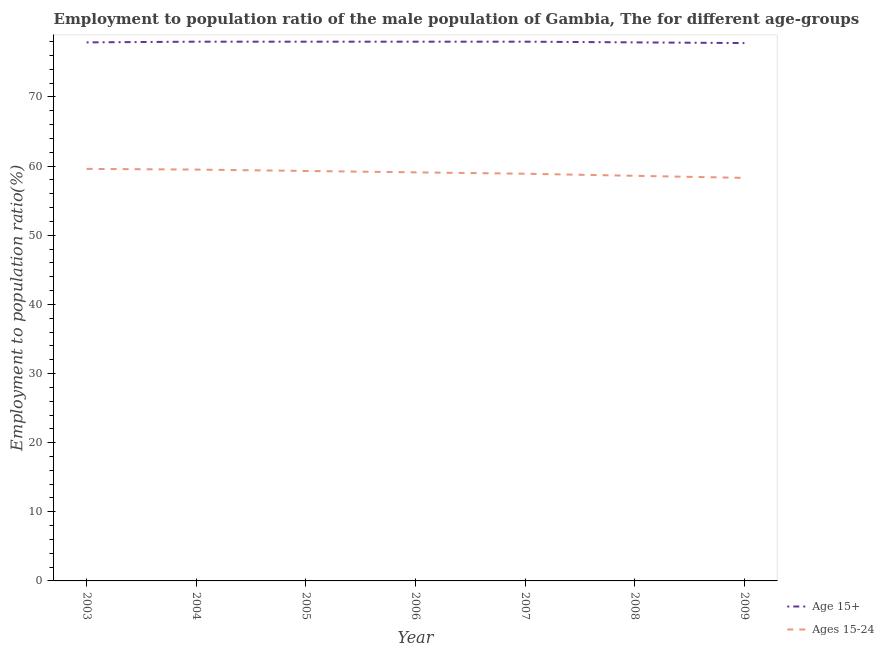How many different coloured lines are there?
Your answer should be compact. 2. Does the line corresponding to employment to population ratio(age 15-24) intersect with the line corresponding to employment to population ratio(age 15+)?
Provide a short and direct response. No. Is the number of lines equal to the number of legend labels?
Provide a succinct answer. Yes. What is the employment to population ratio(age 15+) in 2006?
Your answer should be compact. 78. Across all years, what is the maximum employment to population ratio(age 15-24)?
Your answer should be compact. 59.6. Across all years, what is the minimum employment to population ratio(age 15+)?
Your answer should be very brief. 77.8. In which year was the employment to population ratio(age 15-24) maximum?
Give a very brief answer. 2003. What is the total employment to population ratio(age 15+) in the graph?
Your answer should be very brief. 545.6. What is the difference between the employment to population ratio(age 15-24) in 2004 and that in 2005?
Your answer should be very brief. 0.2. What is the difference between the employment to population ratio(age 15-24) in 2005 and the employment to population ratio(age 15+) in 2007?
Your response must be concise. -18.7. What is the average employment to population ratio(age 15+) per year?
Ensure brevity in your answer.  77.94. In the year 2006, what is the difference between the employment to population ratio(age 15+) and employment to population ratio(age 15-24)?
Offer a very short reply. 18.9. In how many years, is the employment to population ratio(age 15+) greater than 66 %?
Your answer should be compact. 7. What is the ratio of the employment to population ratio(age 15-24) in 2004 to that in 2009?
Your answer should be very brief. 1.02. Is the employment to population ratio(age 15+) in 2007 less than that in 2009?
Give a very brief answer. No. What is the difference between the highest and the second highest employment to population ratio(age 15-24)?
Offer a terse response. 0.1. What is the difference between the highest and the lowest employment to population ratio(age 15+)?
Provide a short and direct response. 0.2. In how many years, is the employment to population ratio(age 15-24) greater than the average employment to population ratio(age 15-24) taken over all years?
Give a very brief answer. 4. Where does the legend appear in the graph?
Ensure brevity in your answer.  Bottom right. How are the legend labels stacked?
Give a very brief answer. Vertical. What is the title of the graph?
Offer a very short reply. Employment to population ratio of the male population of Gambia, The for different age-groups. Does "Merchandise imports" appear as one of the legend labels in the graph?
Offer a very short reply. No. What is the label or title of the X-axis?
Make the answer very short. Year. What is the label or title of the Y-axis?
Give a very brief answer. Employment to population ratio(%). What is the Employment to population ratio(%) in Age 15+ in 2003?
Your answer should be very brief. 77.9. What is the Employment to population ratio(%) of Ages 15-24 in 2003?
Make the answer very short. 59.6. What is the Employment to population ratio(%) of Ages 15-24 in 2004?
Your answer should be very brief. 59.5. What is the Employment to population ratio(%) in Age 15+ in 2005?
Provide a short and direct response. 78. What is the Employment to population ratio(%) of Ages 15-24 in 2005?
Offer a terse response. 59.3. What is the Employment to population ratio(%) in Ages 15-24 in 2006?
Keep it short and to the point. 59.1. What is the Employment to population ratio(%) in Ages 15-24 in 2007?
Offer a terse response. 58.9. What is the Employment to population ratio(%) in Age 15+ in 2008?
Give a very brief answer. 77.9. What is the Employment to population ratio(%) of Ages 15-24 in 2008?
Make the answer very short. 58.6. What is the Employment to population ratio(%) of Age 15+ in 2009?
Your response must be concise. 77.8. What is the Employment to population ratio(%) of Ages 15-24 in 2009?
Make the answer very short. 58.3. Across all years, what is the maximum Employment to population ratio(%) of Age 15+?
Provide a short and direct response. 78. Across all years, what is the maximum Employment to population ratio(%) of Ages 15-24?
Offer a terse response. 59.6. Across all years, what is the minimum Employment to population ratio(%) of Age 15+?
Keep it short and to the point. 77.8. Across all years, what is the minimum Employment to population ratio(%) of Ages 15-24?
Your answer should be very brief. 58.3. What is the total Employment to population ratio(%) of Age 15+ in the graph?
Your response must be concise. 545.6. What is the total Employment to population ratio(%) of Ages 15-24 in the graph?
Ensure brevity in your answer.  413.3. What is the difference between the Employment to population ratio(%) in Ages 15-24 in 2003 and that in 2004?
Your answer should be very brief. 0.1. What is the difference between the Employment to population ratio(%) in Ages 15-24 in 2003 and that in 2005?
Provide a succinct answer. 0.3. What is the difference between the Employment to population ratio(%) of Ages 15-24 in 2003 and that in 2008?
Keep it short and to the point. 1. What is the difference between the Employment to population ratio(%) in Age 15+ in 2003 and that in 2009?
Keep it short and to the point. 0.1. What is the difference between the Employment to population ratio(%) in Ages 15-24 in 2004 and that in 2005?
Provide a succinct answer. 0.2. What is the difference between the Employment to population ratio(%) in Ages 15-24 in 2004 and that in 2006?
Offer a very short reply. 0.4. What is the difference between the Employment to population ratio(%) in Age 15+ in 2004 and that in 2008?
Your answer should be very brief. 0.1. What is the difference between the Employment to population ratio(%) of Age 15+ in 2005 and that in 2006?
Keep it short and to the point. 0. What is the difference between the Employment to population ratio(%) of Age 15+ in 2005 and that in 2007?
Give a very brief answer. 0. What is the difference between the Employment to population ratio(%) in Ages 15-24 in 2005 and that in 2007?
Your response must be concise. 0.4. What is the difference between the Employment to population ratio(%) of Age 15+ in 2005 and that in 2008?
Make the answer very short. 0.1. What is the difference between the Employment to population ratio(%) in Ages 15-24 in 2005 and that in 2009?
Give a very brief answer. 1. What is the difference between the Employment to population ratio(%) in Age 15+ in 2006 and that in 2007?
Provide a short and direct response. 0. What is the difference between the Employment to population ratio(%) of Ages 15-24 in 2006 and that in 2009?
Offer a terse response. 0.8. What is the difference between the Employment to population ratio(%) of Age 15+ in 2007 and that in 2008?
Your answer should be very brief. 0.1. What is the difference between the Employment to population ratio(%) in Ages 15-24 in 2007 and that in 2009?
Give a very brief answer. 0.6. What is the difference between the Employment to population ratio(%) of Age 15+ in 2003 and the Employment to population ratio(%) of Ages 15-24 in 2005?
Give a very brief answer. 18.6. What is the difference between the Employment to population ratio(%) of Age 15+ in 2003 and the Employment to population ratio(%) of Ages 15-24 in 2006?
Provide a succinct answer. 18.8. What is the difference between the Employment to population ratio(%) of Age 15+ in 2003 and the Employment to population ratio(%) of Ages 15-24 in 2007?
Your answer should be very brief. 19. What is the difference between the Employment to population ratio(%) of Age 15+ in 2003 and the Employment to population ratio(%) of Ages 15-24 in 2008?
Provide a short and direct response. 19.3. What is the difference between the Employment to population ratio(%) in Age 15+ in 2003 and the Employment to population ratio(%) in Ages 15-24 in 2009?
Make the answer very short. 19.6. What is the difference between the Employment to population ratio(%) of Age 15+ in 2004 and the Employment to population ratio(%) of Ages 15-24 in 2005?
Your answer should be compact. 18.7. What is the difference between the Employment to population ratio(%) in Age 15+ in 2004 and the Employment to population ratio(%) in Ages 15-24 in 2006?
Make the answer very short. 18.9. What is the difference between the Employment to population ratio(%) of Age 15+ in 2005 and the Employment to population ratio(%) of Ages 15-24 in 2006?
Give a very brief answer. 18.9. What is the difference between the Employment to population ratio(%) in Age 15+ in 2005 and the Employment to population ratio(%) in Ages 15-24 in 2007?
Offer a very short reply. 19.1. What is the difference between the Employment to population ratio(%) in Age 15+ in 2005 and the Employment to population ratio(%) in Ages 15-24 in 2008?
Offer a very short reply. 19.4. What is the difference between the Employment to population ratio(%) of Age 15+ in 2006 and the Employment to population ratio(%) of Ages 15-24 in 2008?
Your answer should be very brief. 19.4. What is the difference between the Employment to population ratio(%) of Age 15+ in 2006 and the Employment to population ratio(%) of Ages 15-24 in 2009?
Make the answer very short. 19.7. What is the difference between the Employment to population ratio(%) in Age 15+ in 2008 and the Employment to population ratio(%) in Ages 15-24 in 2009?
Give a very brief answer. 19.6. What is the average Employment to population ratio(%) in Age 15+ per year?
Provide a succinct answer. 77.94. What is the average Employment to population ratio(%) of Ages 15-24 per year?
Offer a terse response. 59.04. In the year 2003, what is the difference between the Employment to population ratio(%) in Age 15+ and Employment to population ratio(%) in Ages 15-24?
Keep it short and to the point. 18.3. In the year 2006, what is the difference between the Employment to population ratio(%) of Age 15+ and Employment to population ratio(%) of Ages 15-24?
Offer a terse response. 18.9. In the year 2007, what is the difference between the Employment to population ratio(%) in Age 15+ and Employment to population ratio(%) in Ages 15-24?
Your response must be concise. 19.1. In the year 2008, what is the difference between the Employment to population ratio(%) in Age 15+ and Employment to population ratio(%) in Ages 15-24?
Your answer should be very brief. 19.3. In the year 2009, what is the difference between the Employment to population ratio(%) of Age 15+ and Employment to population ratio(%) of Ages 15-24?
Provide a short and direct response. 19.5. What is the ratio of the Employment to population ratio(%) of Age 15+ in 2003 to that in 2005?
Provide a succinct answer. 1. What is the ratio of the Employment to population ratio(%) of Ages 15-24 in 2003 to that in 2005?
Ensure brevity in your answer.  1.01. What is the ratio of the Employment to population ratio(%) in Ages 15-24 in 2003 to that in 2006?
Give a very brief answer. 1.01. What is the ratio of the Employment to population ratio(%) of Age 15+ in 2003 to that in 2007?
Your answer should be very brief. 1. What is the ratio of the Employment to population ratio(%) in Ages 15-24 in 2003 to that in 2007?
Your response must be concise. 1.01. What is the ratio of the Employment to population ratio(%) of Ages 15-24 in 2003 to that in 2008?
Your answer should be compact. 1.02. What is the ratio of the Employment to population ratio(%) of Ages 15-24 in 2003 to that in 2009?
Provide a succinct answer. 1.02. What is the ratio of the Employment to population ratio(%) of Age 15+ in 2004 to that in 2005?
Your answer should be very brief. 1. What is the ratio of the Employment to population ratio(%) of Ages 15-24 in 2004 to that in 2006?
Offer a very short reply. 1.01. What is the ratio of the Employment to population ratio(%) of Ages 15-24 in 2004 to that in 2007?
Give a very brief answer. 1.01. What is the ratio of the Employment to population ratio(%) of Age 15+ in 2004 to that in 2008?
Keep it short and to the point. 1. What is the ratio of the Employment to population ratio(%) of Ages 15-24 in 2004 to that in 2008?
Your answer should be very brief. 1.02. What is the ratio of the Employment to population ratio(%) in Ages 15-24 in 2004 to that in 2009?
Your answer should be very brief. 1.02. What is the ratio of the Employment to population ratio(%) of Age 15+ in 2005 to that in 2007?
Offer a very short reply. 1. What is the ratio of the Employment to population ratio(%) in Ages 15-24 in 2005 to that in 2007?
Your answer should be compact. 1.01. What is the ratio of the Employment to population ratio(%) of Age 15+ in 2005 to that in 2008?
Ensure brevity in your answer.  1. What is the ratio of the Employment to population ratio(%) in Ages 15-24 in 2005 to that in 2008?
Your answer should be very brief. 1.01. What is the ratio of the Employment to population ratio(%) in Ages 15-24 in 2005 to that in 2009?
Offer a very short reply. 1.02. What is the ratio of the Employment to population ratio(%) in Age 15+ in 2006 to that in 2008?
Offer a terse response. 1. What is the ratio of the Employment to population ratio(%) in Ages 15-24 in 2006 to that in 2008?
Keep it short and to the point. 1.01. What is the ratio of the Employment to population ratio(%) in Age 15+ in 2006 to that in 2009?
Offer a very short reply. 1. What is the ratio of the Employment to population ratio(%) of Ages 15-24 in 2006 to that in 2009?
Give a very brief answer. 1.01. What is the ratio of the Employment to population ratio(%) of Age 15+ in 2007 to that in 2008?
Your answer should be compact. 1. What is the ratio of the Employment to population ratio(%) of Ages 15-24 in 2007 to that in 2008?
Offer a terse response. 1.01. What is the ratio of the Employment to population ratio(%) of Age 15+ in 2007 to that in 2009?
Provide a succinct answer. 1. What is the ratio of the Employment to population ratio(%) of Ages 15-24 in 2007 to that in 2009?
Provide a succinct answer. 1.01. What is the ratio of the Employment to population ratio(%) in Age 15+ in 2008 to that in 2009?
Offer a very short reply. 1. What is the ratio of the Employment to population ratio(%) in Ages 15-24 in 2008 to that in 2009?
Your answer should be compact. 1.01. What is the difference between the highest and the second highest Employment to population ratio(%) in Ages 15-24?
Your response must be concise. 0.1. What is the difference between the highest and the lowest Employment to population ratio(%) of Age 15+?
Offer a terse response. 0.2. 